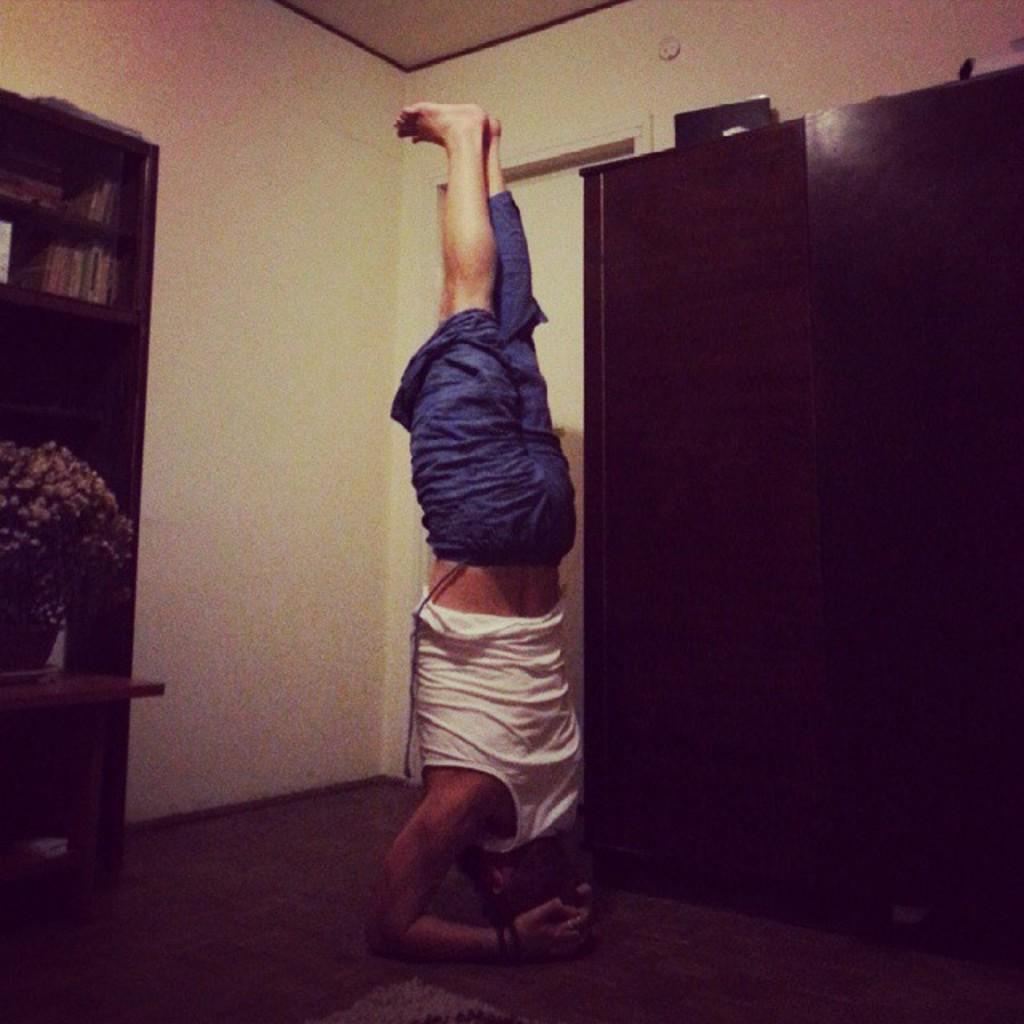What is the position of the person in the image? The person is standing upside down in the image. What activity is the person engaged in? The person is doing exercise in the image. What can be seen in the background of the image? There are wardrobes made of wood in the background of the image. What type of metal is used to make the sisters' jewelry in the image? There are no sisters or jewelry present in the image; it features a person doing exercise while standing upside down. 